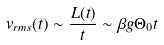Convert formula to latex. <formula><loc_0><loc_0><loc_500><loc_500>v _ { r m s } ( t ) \sim \frac { L ( t ) } { t } \sim \beta g \Theta _ { 0 } t</formula> 